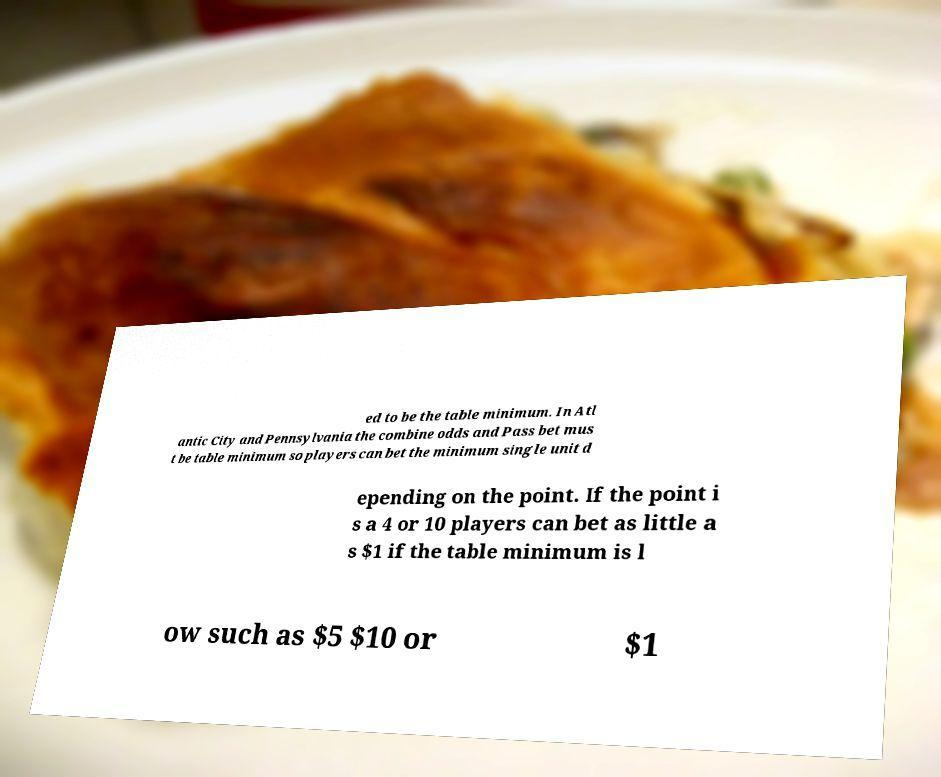Could you assist in decoding the text presented in this image and type it out clearly? ed to be the table minimum. In Atl antic City and Pennsylvania the combine odds and Pass bet mus t be table minimum so players can bet the minimum single unit d epending on the point. If the point i s a 4 or 10 players can bet as little a s $1 if the table minimum is l ow such as $5 $10 or $1 